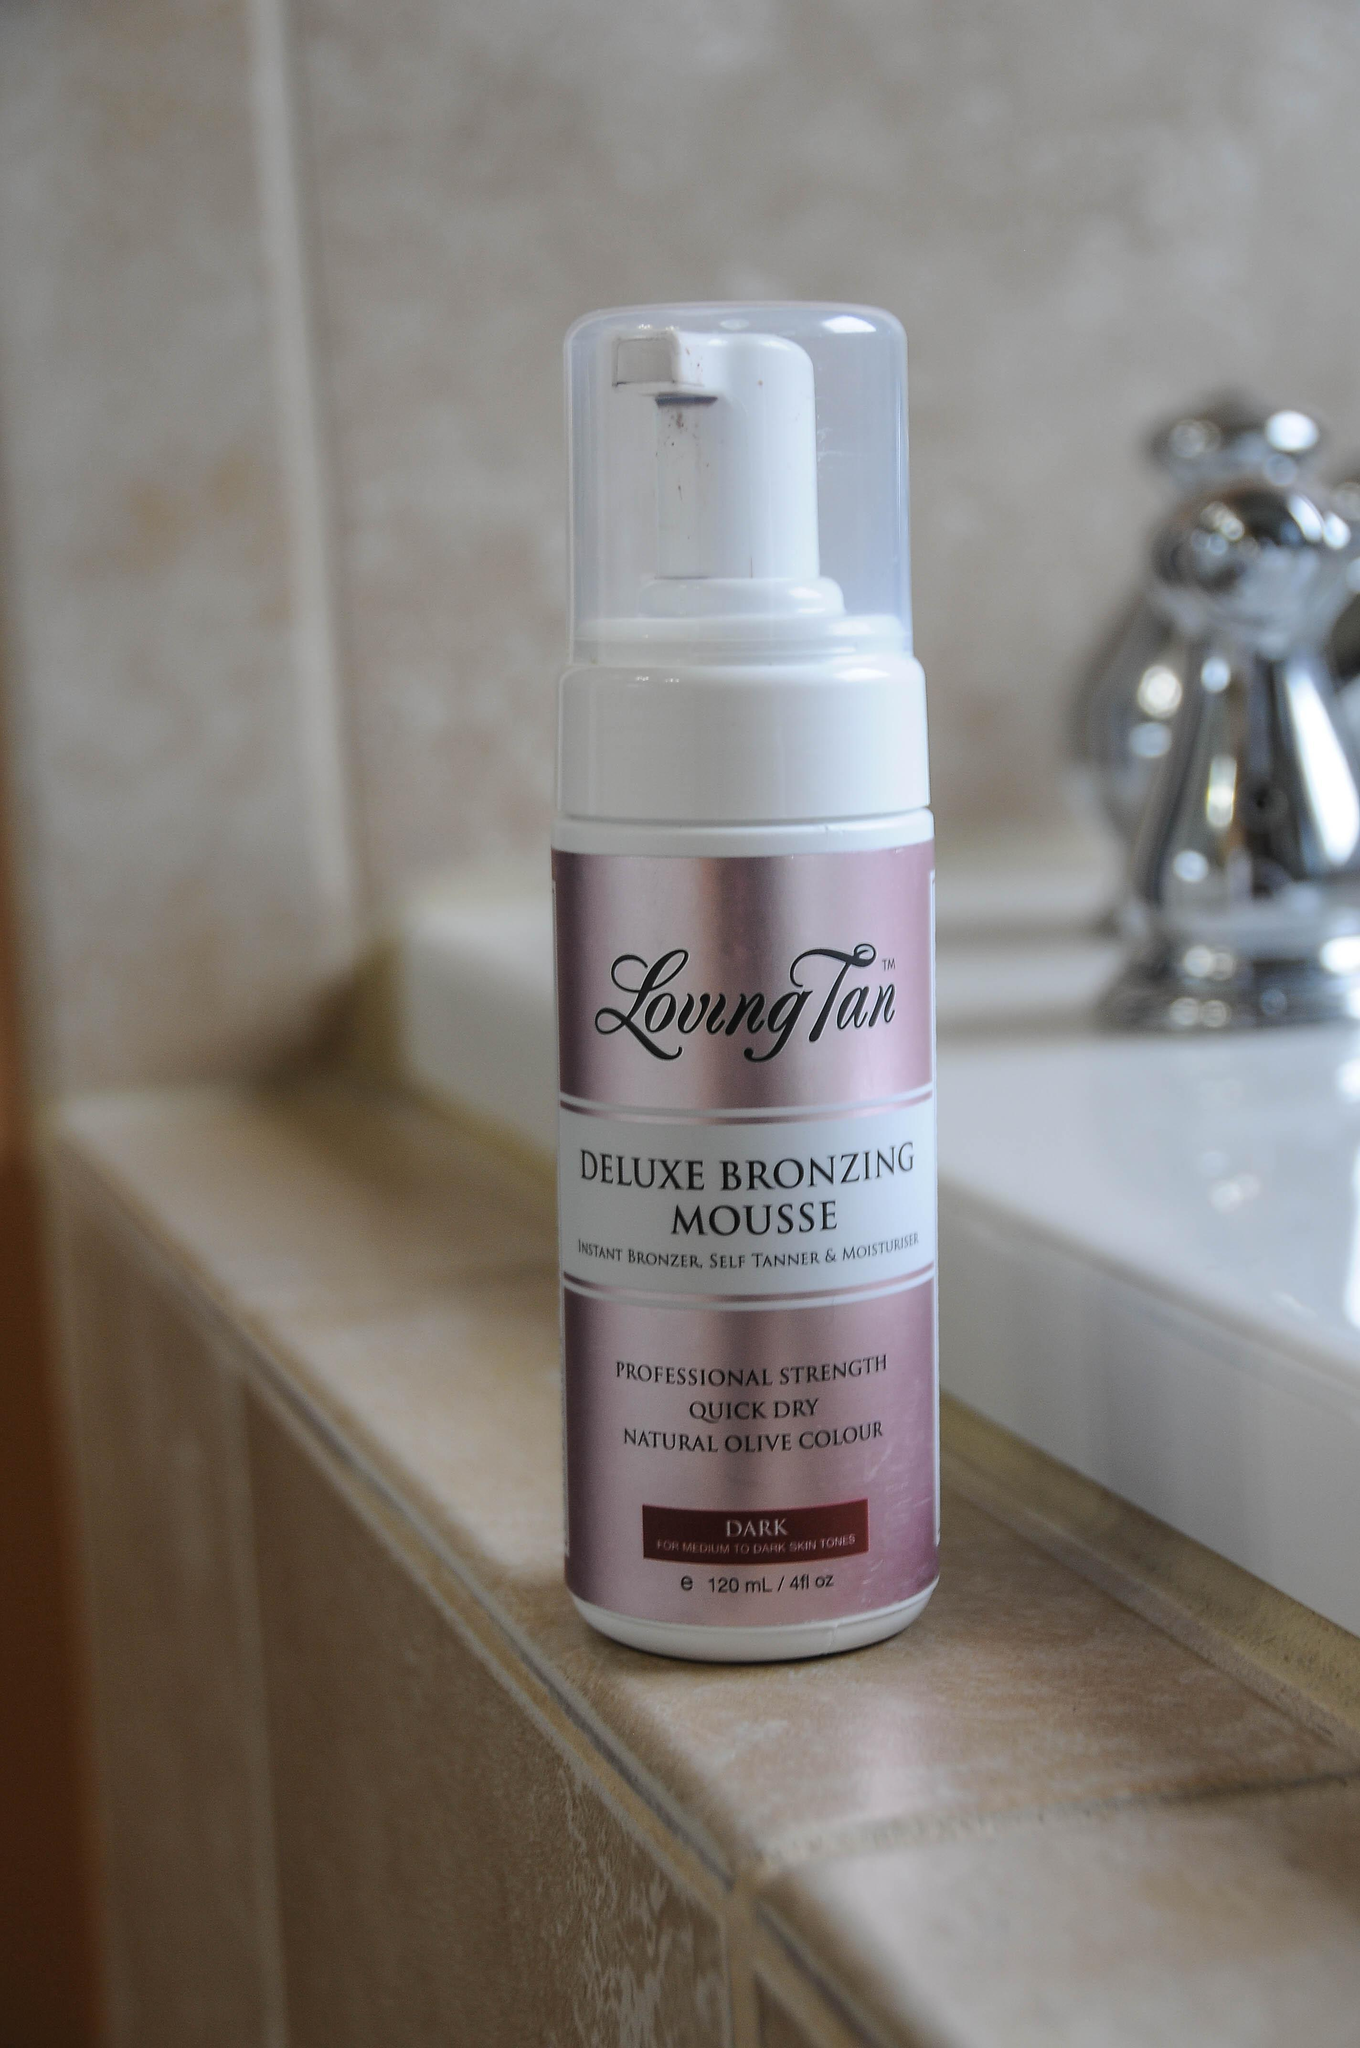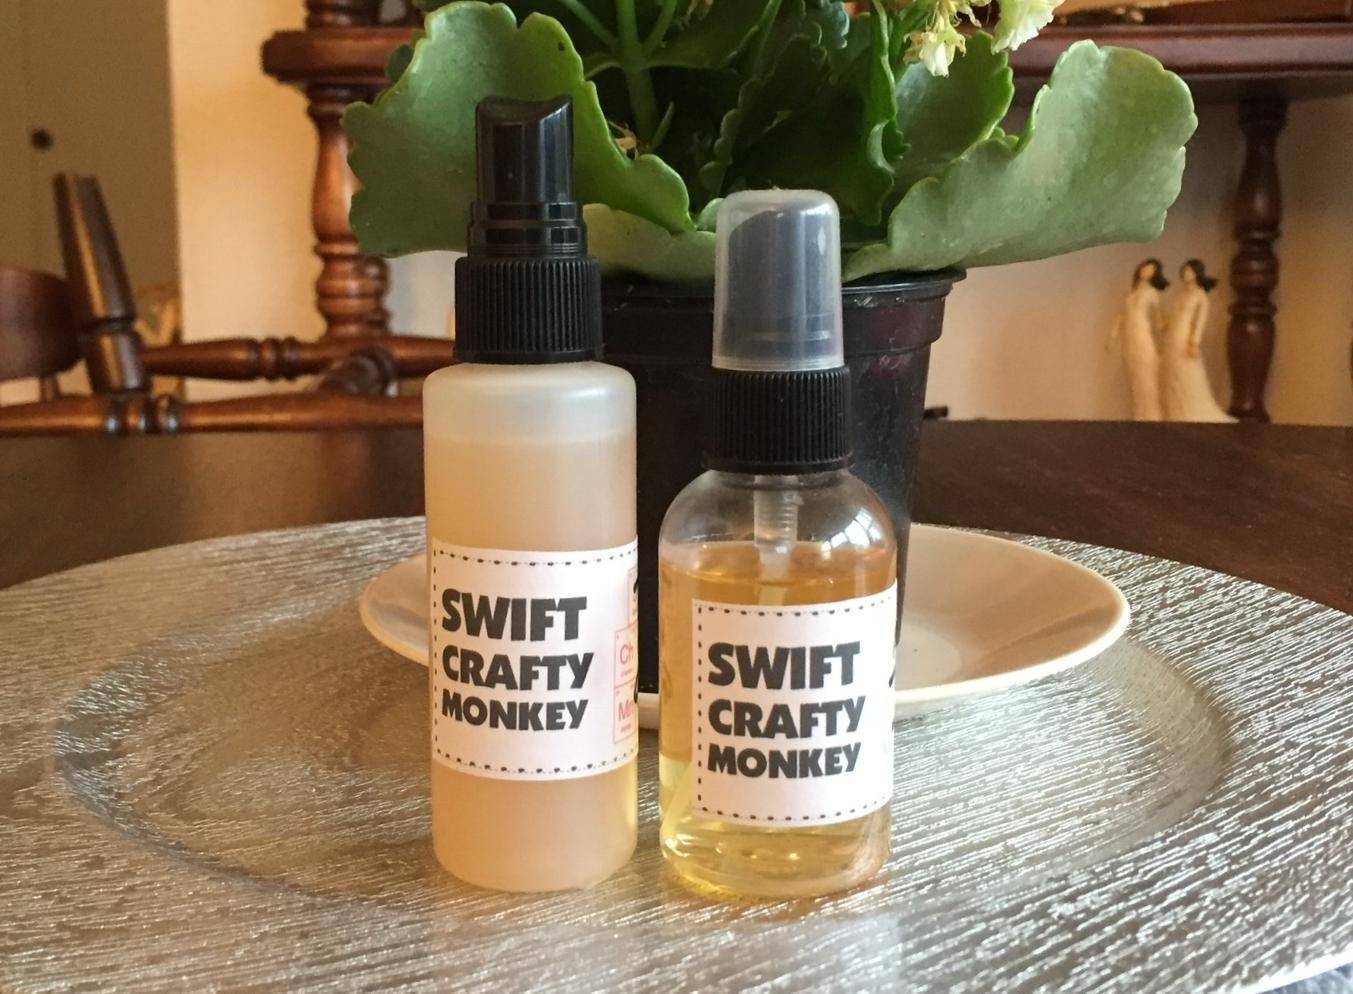The first image is the image on the left, the second image is the image on the right. Considering the images on both sides, is "In at least one image there is a row of three of the same brand moisturizer." valid? Answer yes or no. No. The first image is the image on the left, the second image is the image on the right. For the images shown, is this caption "Some items are on store shelves." true? Answer yes or no. No. 